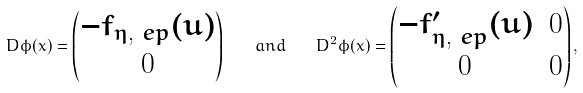<formula> <loc_0><loc_0><loc_500><loc_500>D \phi ( x ) = \begin{pmatrix} - f _ { \eta , \ e p } ( u ) \\ 0 \end{pmatrix} \quad a n d \quad D ^ { 2 } \phi ( x ) = \begin{pmatrix} - f _ { \eta , \ e p } ^ { \prime } ( u ) & 0 \\ 0 & 0 \end{pmatrix} ,</formula> 